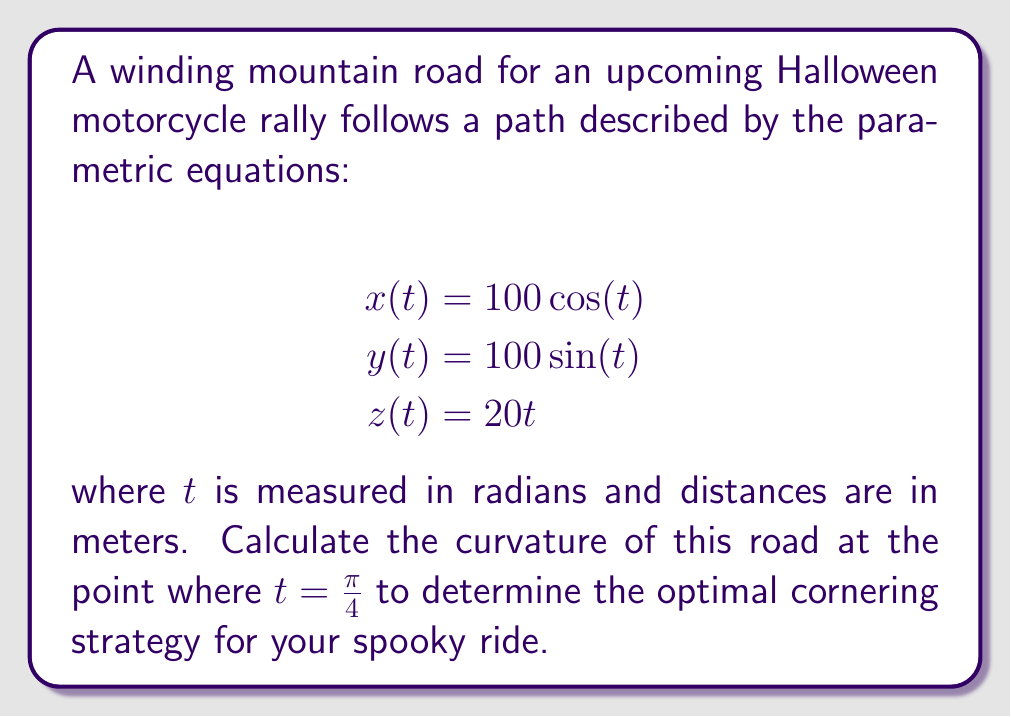Can you solve this math problem? To calculate the curvature of the road, we'll use the formula for the curvature of a space curve:

$$\kappa = \frac{\|\mathbf{r}'(t) \times \mathbf{r}''(t)\|}{\|\mathbf{r}'(t)\|^3}$$

where $\mathbf{r}(t) = (x(t), y(t), z(t))$ is the position vector.

Step 1: Calculate $\mathbf{r}'(t)$
$$\mathbf{r}'(t) = (-100\sin(t), 100\cos(t), 20)$$

Step 2: Calculate $\mathbf{r}''(t)$
$$\mathbf{r}''(t) = (-100\cos(t), -100\sin(t), 0)$$

Step 3: Calculate $\mathbf{r}'(t) \times \mathbf{r}''(t)$
$$\mathbf{r}'(t) \times \mathbf{r}''(t) = (2000\sin(t), -2000\cos(t), 10000)$$

Step 4: Calculate $\|\mathbf{r}'(t) \times \mathbf{r}''(t)\|$
$$\|\mathbf{r}'(t) \times \mathbf{r}''(t)\| = \sqrt{4,000,000\sin^2(t) + 4,000,000\cos^2(t) + 100,000,000} = \sqrt{104,000,000}$$

Step 5: Calculate $\|\mathbf{r}'(t)\|$
$$\|\mathbf{r}'(t)\| = \sqrt{10000\sin^2(t) + 10000\cos^2(t) + 400} = \sqrt{10400}$$

Step 6: Apply the curvature formula at $t = \frac{\pi}{4}$
$$\kappa = \frac{\sqrt{104,000,000}}{(\sqrt{10400})^3} = \frac{\sqrt{104,000,000}}{1,061,208} \approx 0.00962$$

The curvature is constant for all $t$ because the road follows a helical path with constant pitch and radius.
Answer: The curvature of the mountain road at $t = \frac{\pi}{4}$ (and at all points) is approximately 0.00962 m^(-1). 